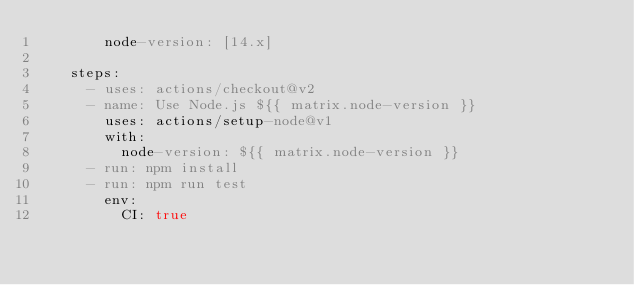Convert code to text. <code><loc_0><loc_0><loc_500><loc_500><_YAML_>        node-version: [14.x]

    steps:
      - uses: actions/checkout@v2
      - name: Use Node.js ${{ matrix.node-version }}
        uses: actions/setup-node@v1
        with:
          node-version: ${{ matrix.node-version }}
      - run: npm install
      - run: npm run test
        env:
          CI: true
</code> 